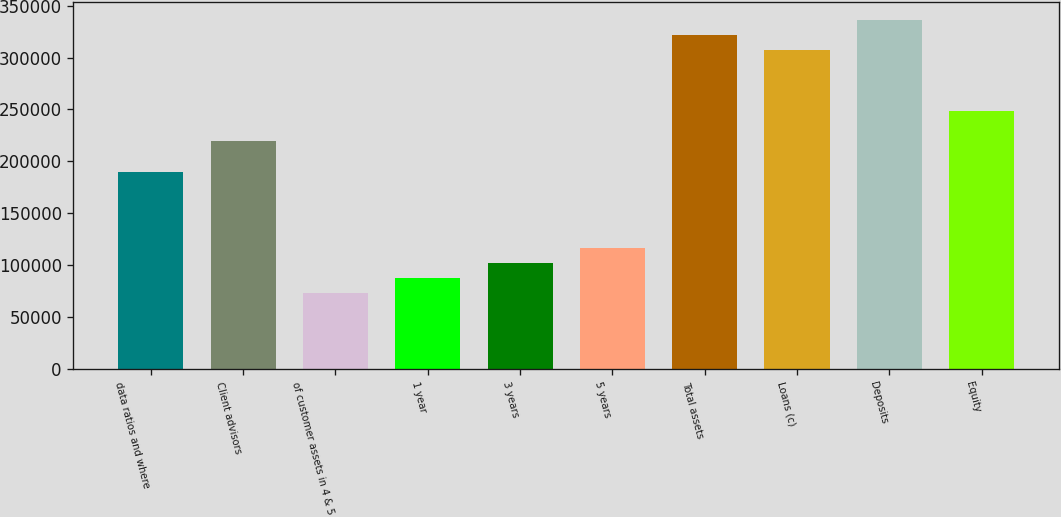Convert chart to OTSL. <chart><loc_0><loc_0><loc_500><loc_500><bar_chart><fcel>data ratios and where<fcel>Client advisors<fcel>of customer assets in 4 & 5<fcel>1 year<fcel>3 years<fcel>5 years<fcel>Total assets<fcel>Loans (c)<fcel>Deposits<fcel>Equity<nl><fcel>190038<fcel>219274<fcel>73091.5<fcel>87709.8<fcel>102328<fcel>116946<fcel>321603<fcel>306984<fcel>336221<fcel>248511<nl></chart> 